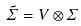Convert formula to latex. <formula><loc_0><loc_0><loc_500><loc_500>\tilde { \Sigma } = V \otimes \Sigma</formula> 